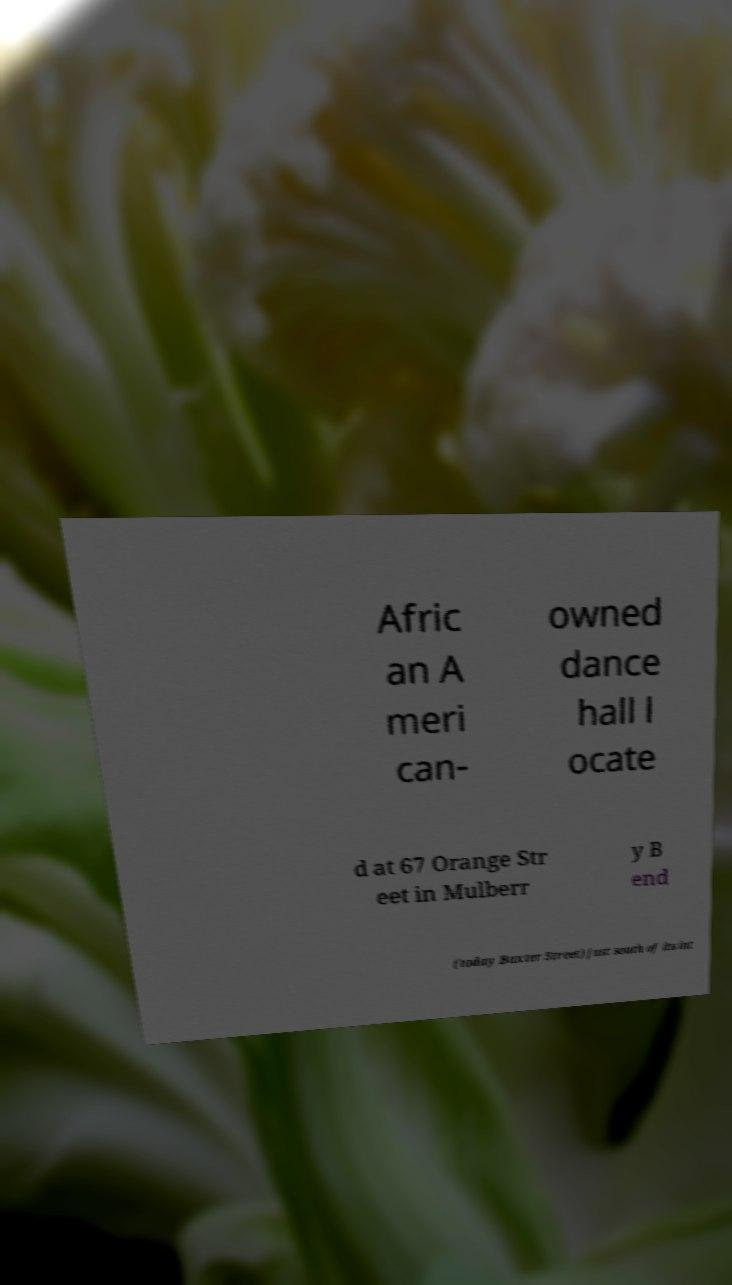Can you read and provide the text displayed in the image?This photo seems to have some interesting text. Can you extract and type it out for me? Afric an A meri can- owned dance hall l ocate d at 67 Orange Str eet in Mulberr y B end (today Baxter Street) just south of its int 